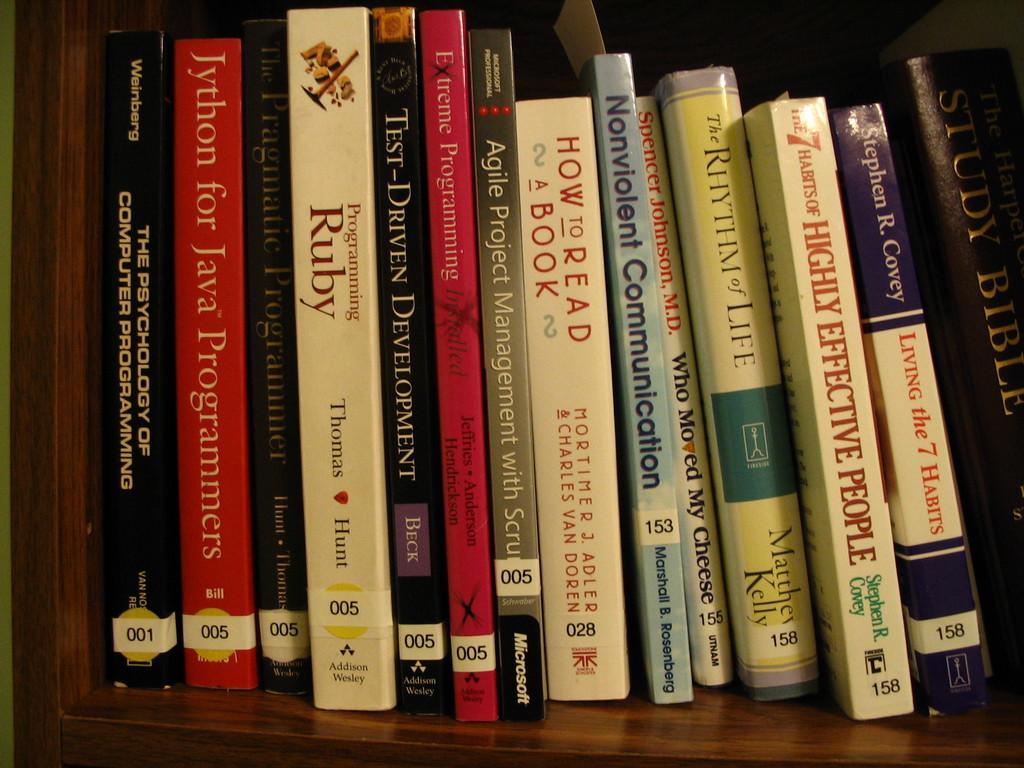Who wrote programming ruby?
Your answer should be compact. Thomas hunt. Who wrote highly effective people?
Provide a succinct answer. Stephen r. covey. 